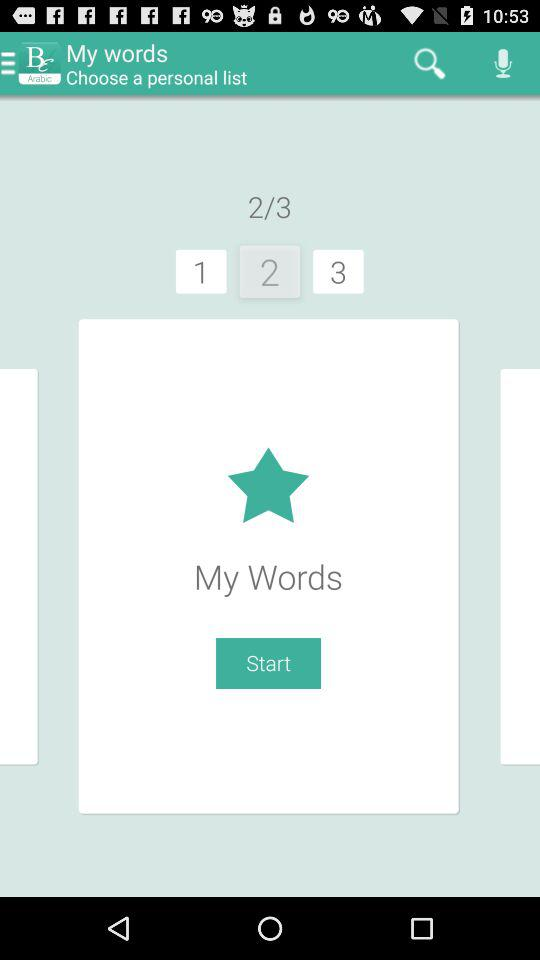How many lists in total are shown? There are 3 lists. 